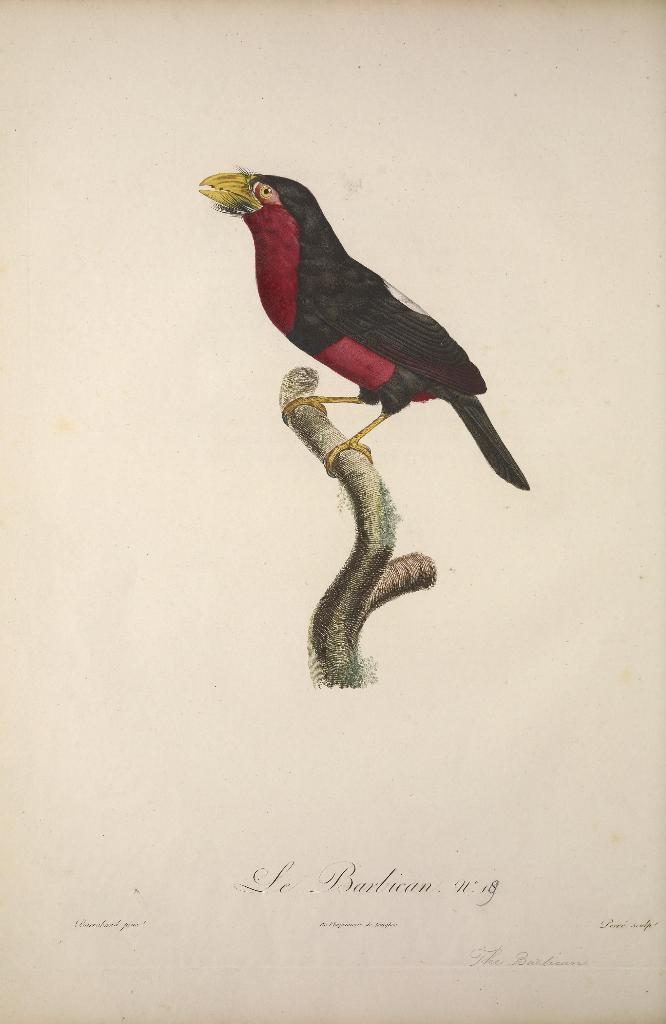What is present on the paper in the image? There is a bird on the paper in the image. Where is the bird located on the paper? The bird is on a tree branch in the image. How many snails can be seen crawling on the paper in the image? There are no snails present in the image. Can you provide an example of a similar image with a different animal? The provided facts do not allow for a comparison to a different image, as we only have information about this specific image. 